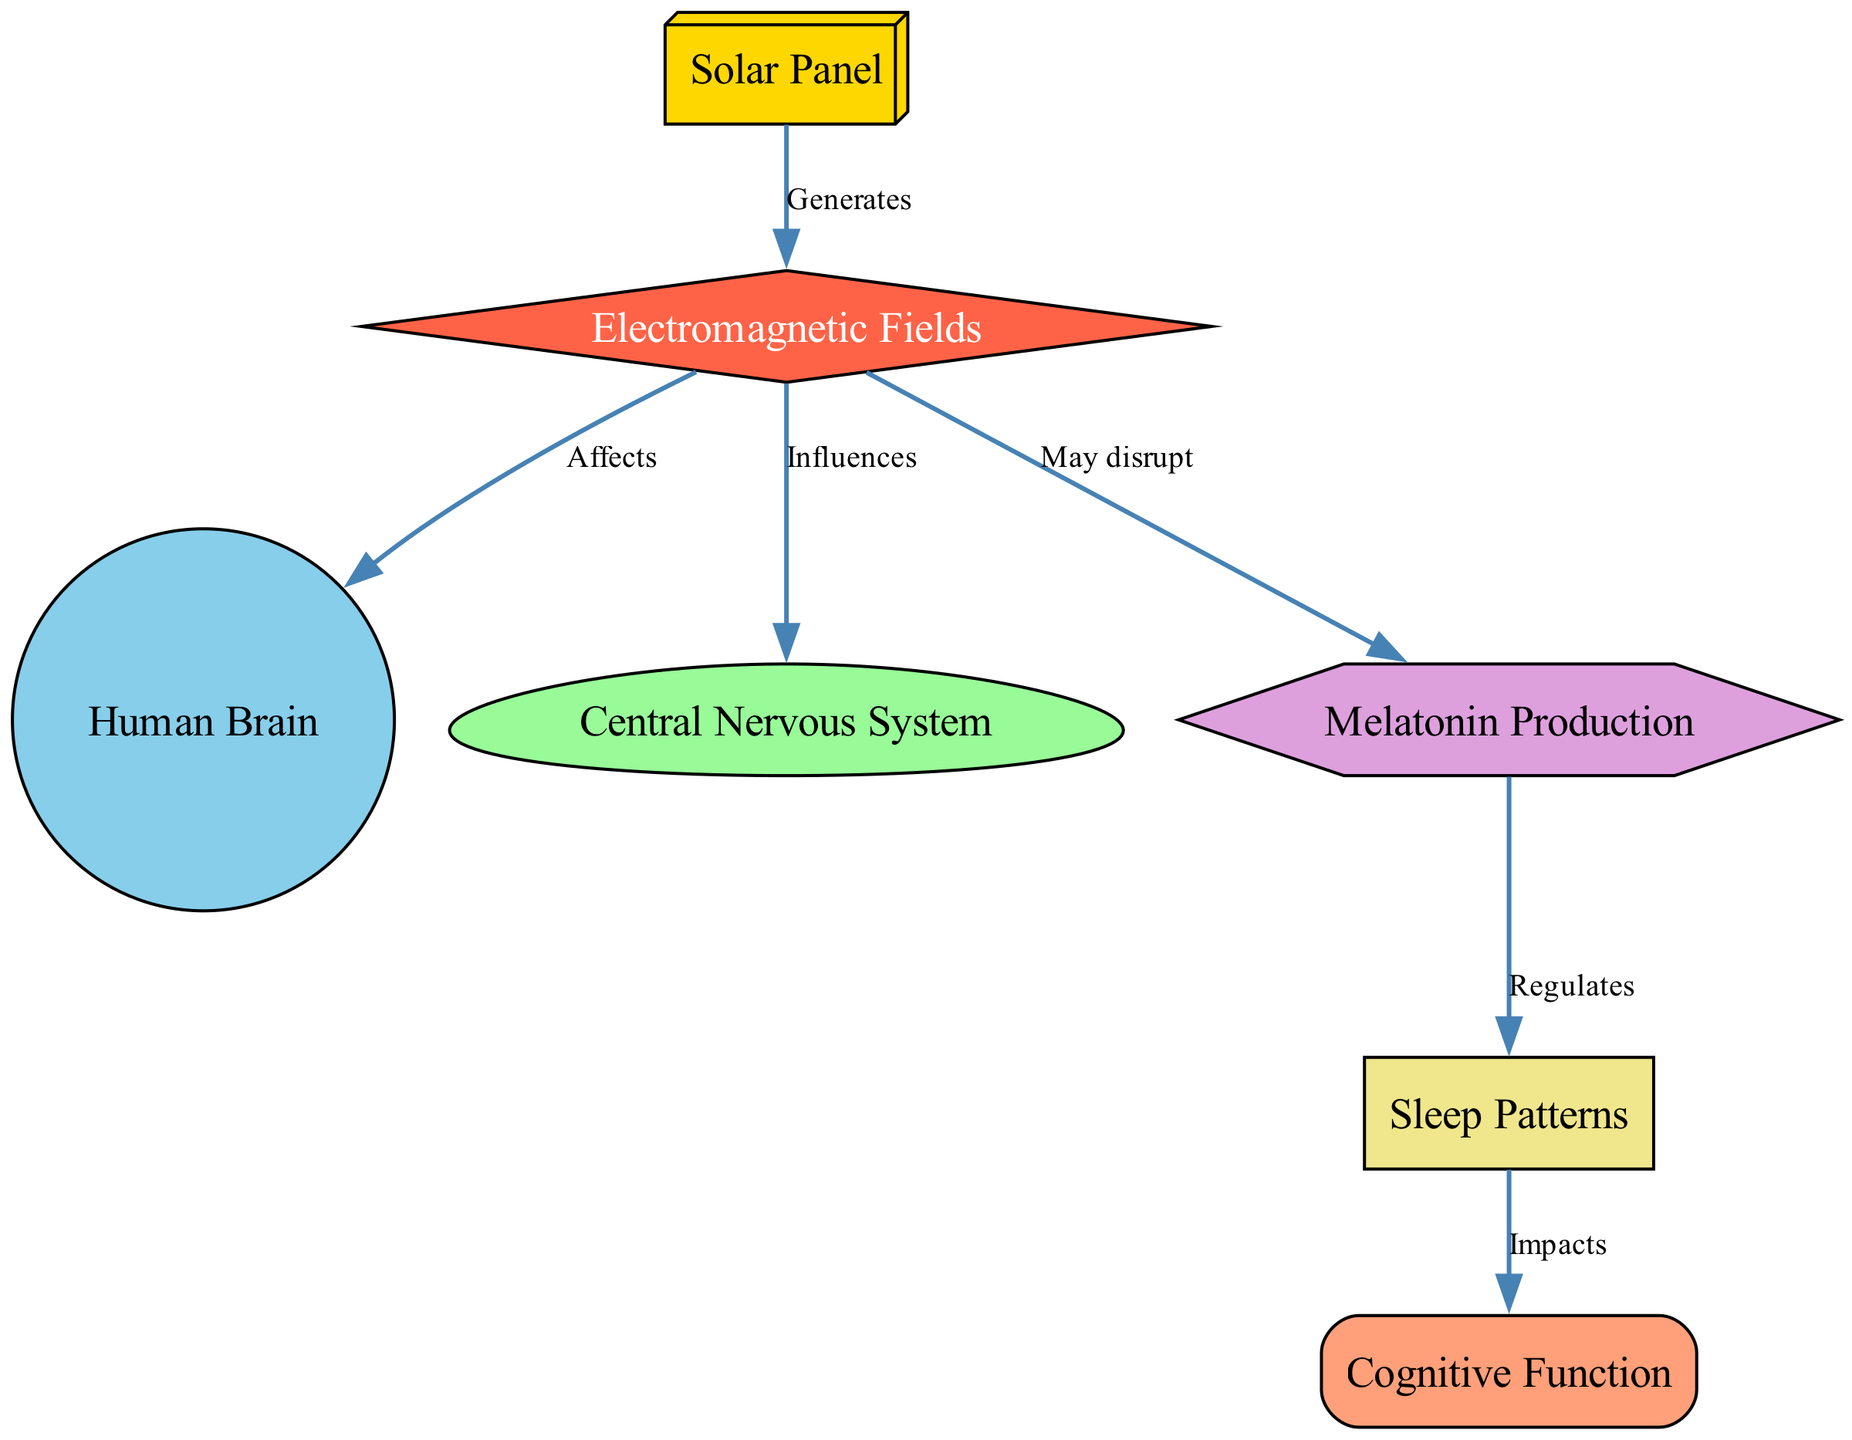What is the total number of nodes in the diagram? The diagram contains a list of various entities, specifically nodes representing "Solar Panel," "Electromagnetic Fields," "Human Brain," "Central Nervous System," "Melatonin Production," "Sleep Patterns," and "Cognitive Function." Counting these nodes, we find there are a total of seven distinct nodes.
Answer: 7 What type of effect do electromagnetic fields have on the brain? According to the diagram, the edge labeled "Affects" connects "Electromagnetic Fields" to "Human Brain," indicating that there is a direct influence or effect of electromagnetic fields on the brain.
Answer: Affects Which node regulates sleep patterns? The diagram clearly shows that "Melatonin Production" is connected to "Sleep Patterns" by an edge labeled "Regulates." This indicates that melatonin plays a regulatory role in sleep patterns.
Answer: Melatonin Production What is the relationship between sleep patterns and cognitive function? The diagram illustrates an edge labeled "Impacts" that connects "Sleep Patterns" to "Cognitive Function," showing that changes or variations in sleep patterns are likely to influence cognitive function.
Answer: Impacts How many edges are present in the diagram? By examining the connections (edges) between the nodes, we see there are a total of six relationships illustrated, since each edge displays a link between two different nodes in the diagram.
Answer: 6 What may be disrupted by electromagnetic fields? The diagram indicates that "Electromagnetic Fields" may disrupt the "Melatonin Production" node, as indicated by the edge labeled "May disrupt." This describes potential negative effects on melatonin synthesis.
Answer: Melatonin Production Which node influences the central nervous system? The edge labeled "Influences" points from "Electromagnetic Fields" to "Central Nervous System," indicating that electromagnetic fields exert some level of influence over the nervous system.
Answer: Central Nervous System What might be the consequence of disrupted sleep patterns? The diagram suggests that if sleep patterns are impacted, it may lead to effects on "Cognitive Function," as indicated by the edge labeled "Impacts." This means that changes in sleep could have consequences on cognitive abilities.
Answer: Cognitive Function 